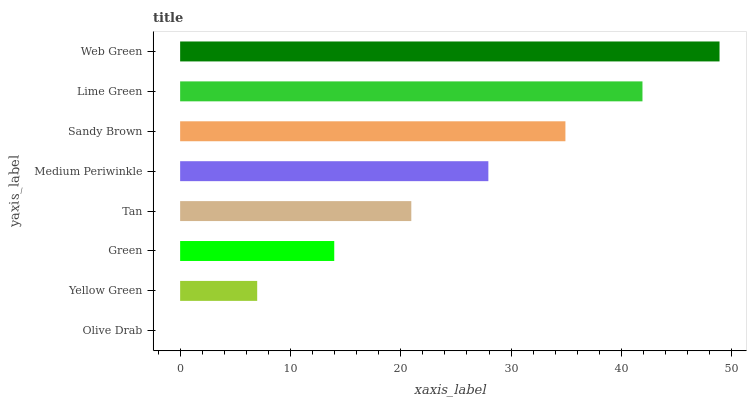Is Olive Drab the minimum?
Answer yes or no. Yes. Is Web Green the maximum?
Answer yes or no. Yes. Is Yellow Green the minimum?
Answer yes or no. No. Is Yellow Green the maximum?
Answer yes or no. No. Is Yellow Green greater than Olive Drab?
Answer yes or no. Yes. Is Olive Drab less than Yellow Green?
Answer yes or no. Yes. Is Olive Drab greater than Yellow Green?
Answer yes or no. No. Is Yellow Green less than Olive Drab?
Answer yes or no. No. Is Medium Periwinkle the high median?
Answer yes or no. Yes. Is Tan the low median?
Answer yes or no. Yes. Is Yellow Green the high median?
Answer yes or no. No. Is Olive Drab the low median?
Answer yes or no. No. 